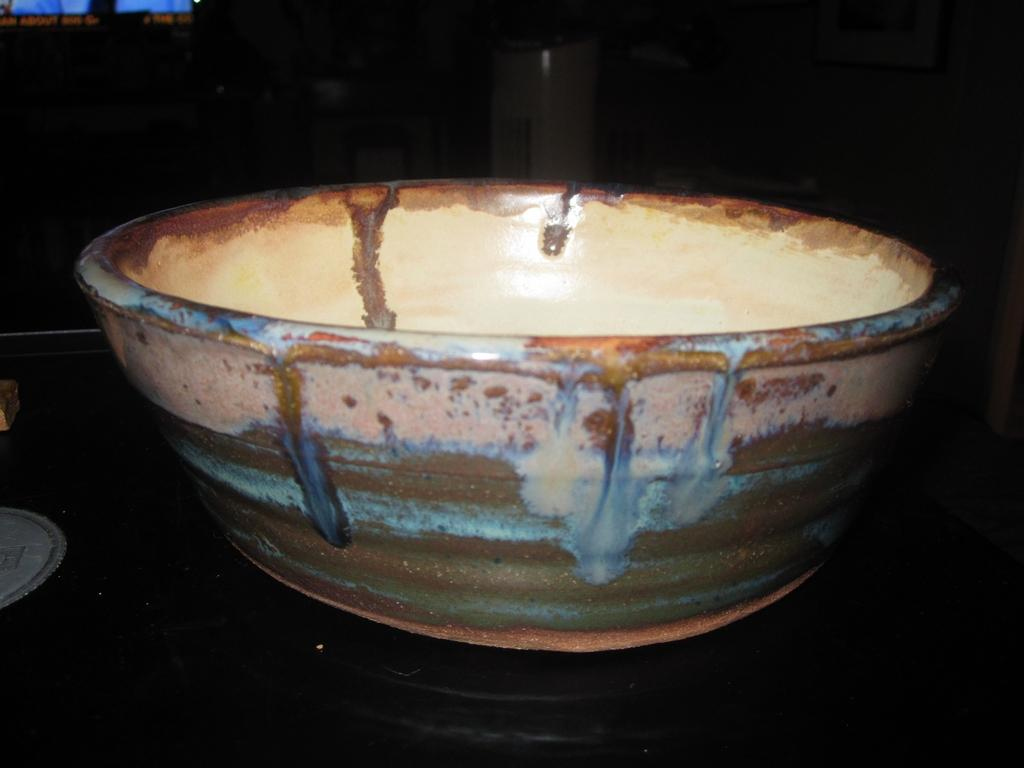What piece of furniture is present in the image? There is a table in the image. What is on top of the table? There is a bowl on the table. What can be seen in the background of the image? There is a window and a wall in the background of the image. How is the background of the image depicted? The background is blurred. What type of flesh can be seen hanging from the wall in the image? There is no flesh present in the image; the wall is part of the background and is blurred. 